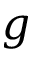Convert formula to latex. <formula><loc_0><loc_0><loc_500><loc_500>g</formula> 